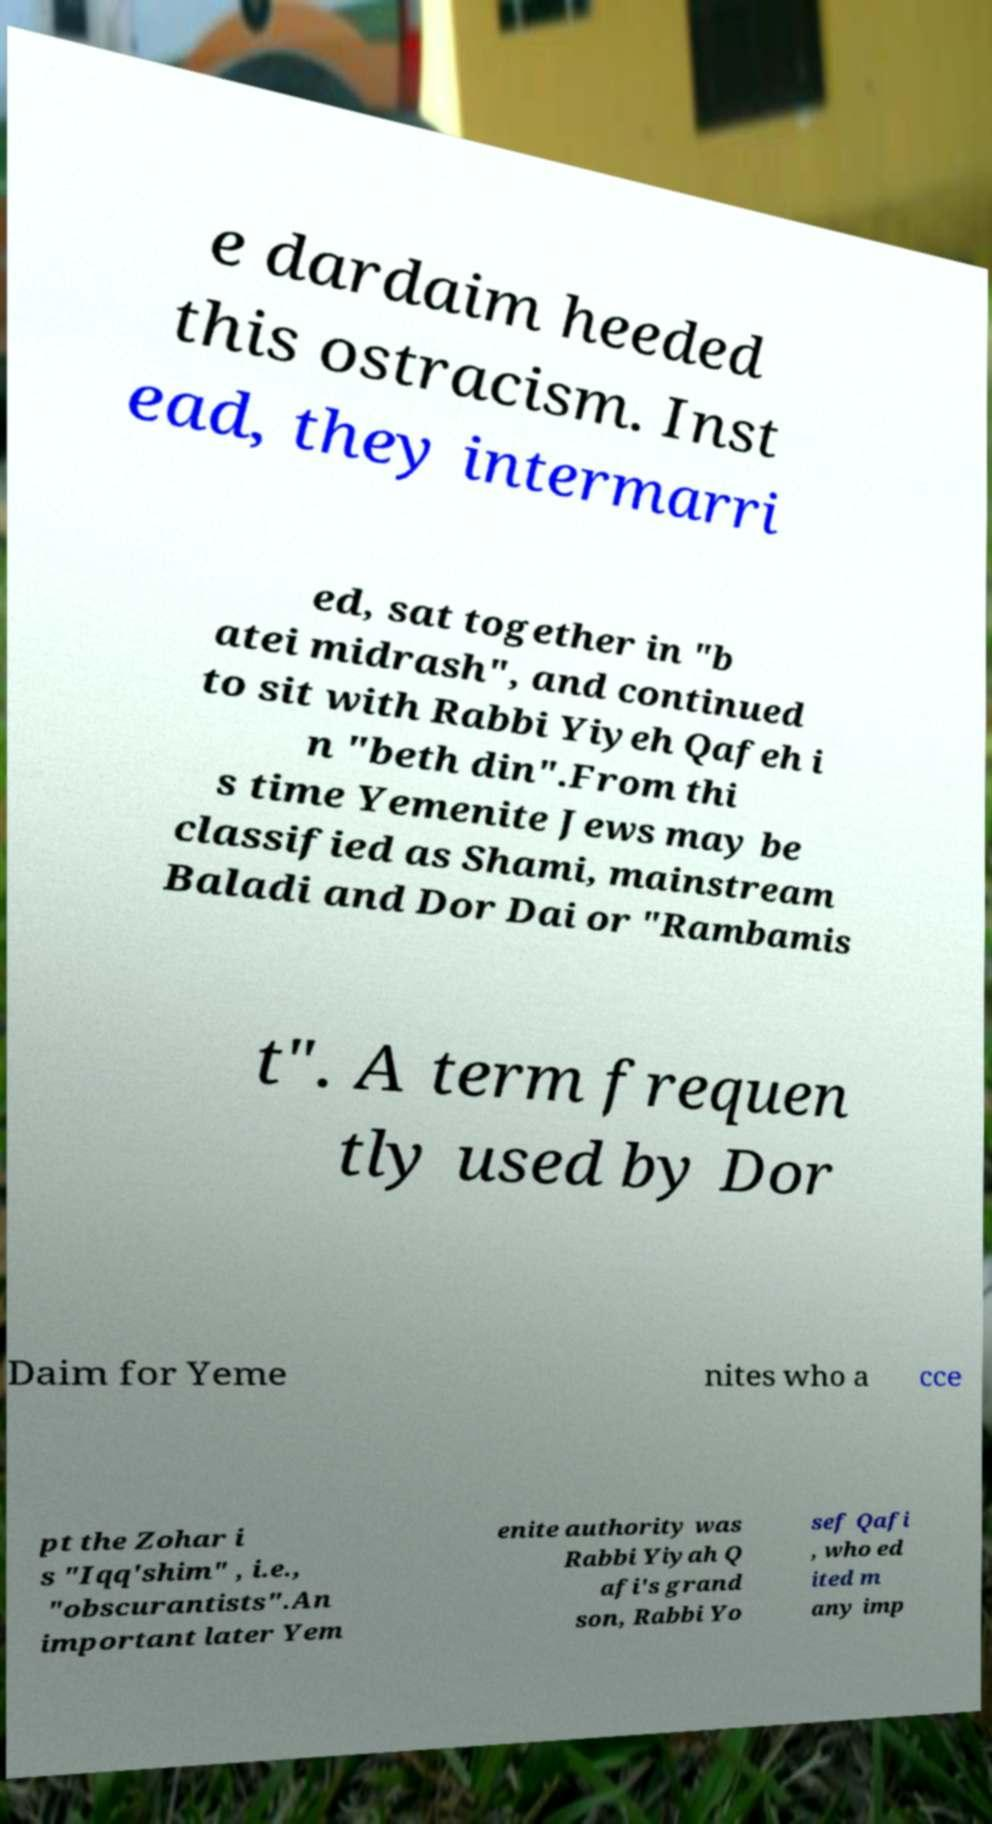Can you read and provide the text displayed in the image?This photo seems to have some interesting text. Can you extract and type it out for me? e dardaim heeded this ostracism. Inst ead, they intermarri ed, sat together in "b atei midrash", and continued to sit with Rabbi Yiyeh Qafeh i n "beth din".From thi s time Yemenite Jews may be classified as Shami, mainstream Baladi and Dor Dai or "Rambamis t". A term frequen tly used by Dor Daim for Yeme nites who a cce pt the Zohar i s "Iqq'shim" , i.e., "obscurantists".An important later Yem enite authority was Rabbi Yiyah Q afi's grand son, Rabbi Yo sef Qafi , who ed ited m any imp 